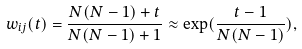Convert formula to latex. <formula><loc_0><loc_0><loc_500><loc_500>w _ { i j } ( t ) = \frac { N ( N - 1 ) + t } { N ( N - 1 ) + 1 } \approx \exp ( \frac { t - 1 } { N ( N - 1 ) } ) ,</formula> 